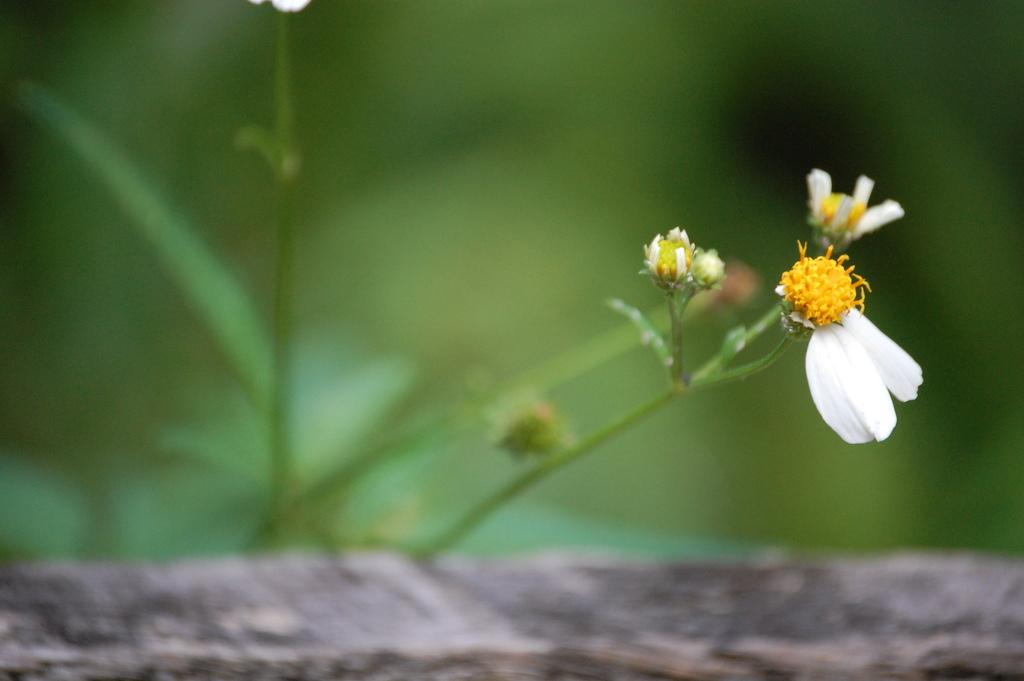What type of plant can be seen on the right side of the image? There is a flower on the right side of the image. What type of credit card is being used to purchase the flower in the image? There is no credit card or purchase being depicted in the image; it only shows a flower on the right side. 